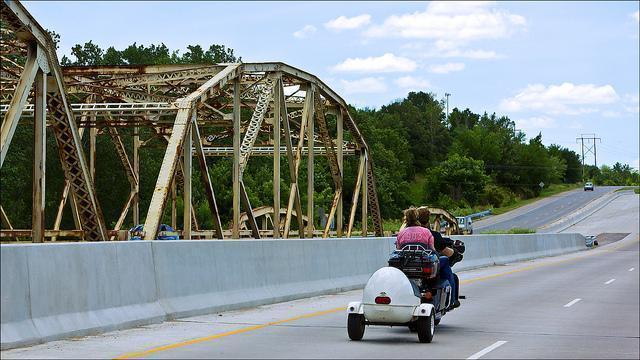What is next to the vehicle?
Select the accurate response from the four choices given to answer the question.
Options: Walrus, antelope, airplane, bridge. Bridge. 